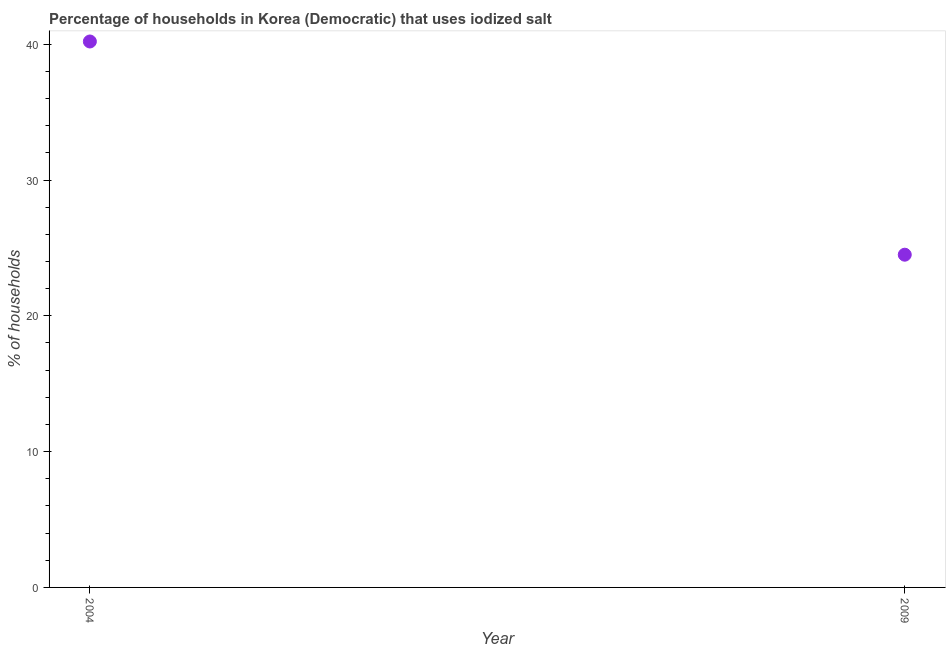What is the percentage of households where iodized salt is consumed in 2009?
Ensure brevity in your answer.  24.5. Across all years, what is the maximum percentage of households where iodized salt is consumed?
Offer a terse response. 40.2. In which year was the percentage of households where iodized salt is consumed maximum?
Your answer should be very brief. 2004. In which year was the percentage of households where iodized salt is consumed minimum?
Ensure brevity in your answer.  2009. What is the sum of the percentage of households where iodized salt is consumed?
Make the answer very short. 64.7. What is the difference between the percentage of households where iodized salt is consumed in 2004 and 2009?
Ensure brevity in your answer.  15.7. What is the average percentage of households where iodized salt is consumed per year?
Offer a terse response. 32.35. What is the median percentage of households where iodized salt is consumed?
Give a very brief answer. 32.35. In how many years, is the percentage of households where iodized salt is consumed greater than 16 %?
Your answer should be compact. 2. What is the ratio of the percentage of households where iodized salt is consumed in 2004 to that in 2009?
Ensure brevity in your answer.  1.64. In how many years, is the percentage of households where iodized salt is consumed greater than the average percentage of households where iodized salt is consumed taken over all years?
Your answer should be very brief. 1. Does the percentage of households where iodized salt is consumed monotonically increase over the years?
Offer a very short reply. No. How many dotlines are there?
Provide a succinct answer. 1. How many years are there in the graph?
Ensure brevity in your answer.  2. What is the difference between two consecutive major ticks on the Y-axis?
Offer a very short reply. 10. Are the values on the major ticks of Y-axis written in scientific E-notation?
Your answer should be compact. No. Does the graph contain grids?
Your response must be concise. No. What is the title of the graph?
Ensure brevity in your answer.  Percentage of households in Korea (Democratic) that uses iodized salt. What is the label or title of the X-axis?
Keep it short and to the point. Year. What is the label or title of the Y-axis?
Keep it short and to the point. % of households. What is the % of households in 2004?
Provide a succinct answer. 40.2. What is the % of households in 2009?
Offer a terse response. 24.5. What is the ratio of the % of households in 2004 to that in 2009?
Give a very brief answer. 1.64. 